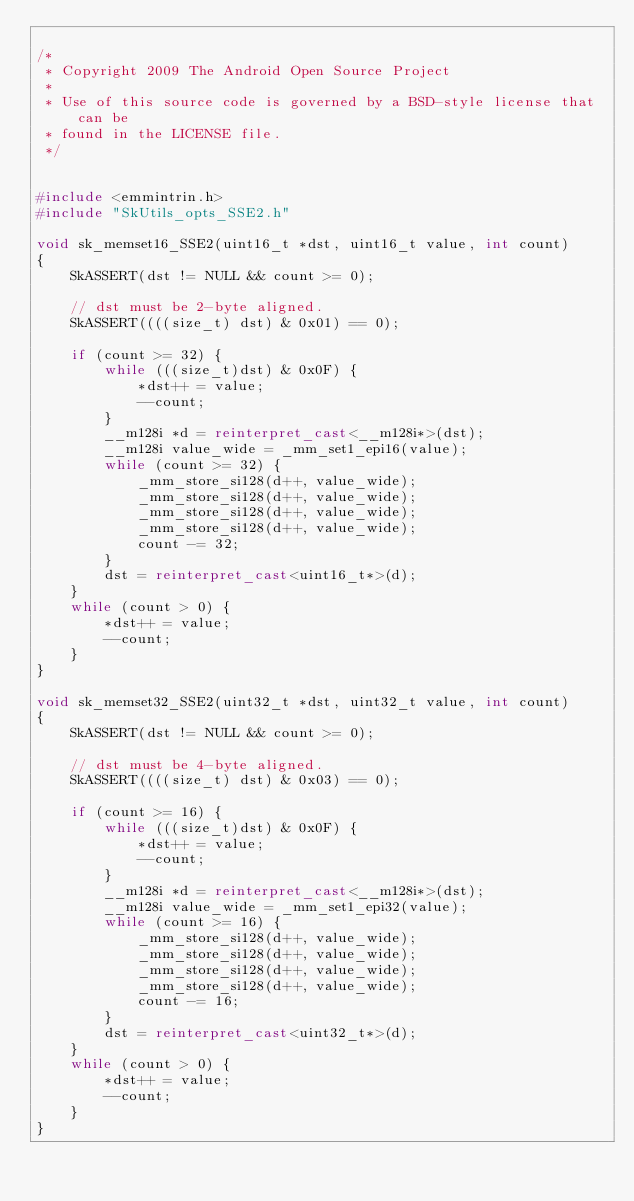<code> <loc_0><loc_0><loc_500><loc_500><_C++_>
/*
 * Copyright 2009 The Android Open Source Project
 *
 * Use of this source code is governed by a BSD-style license that can be
 * found in the LICENSE file.
 */


#include <emmintrin.h>
#include "SkUtils_opts_SSE2.h"

void sk_memset16_SSE2(uint16_t *dst, uint16_t value, int count)
{
    SkASSERT(dst != NULL && count >= 0);

    // dst must be 2-byte aligned.
    SkASSERT((((size_t) dst) & 0x01) == 0);

    if (count >= 32) {
        while (((size_t)dst) & 0x0F) {
            *dst++ = value;
            --count;
        }
        __m128i *d = reinterpret_cast<__m128i*>(dst);
        __m128i value_wide = _mm_set1_epi16(value);
        while (count >= 32) {
            _mm_store_si128(d++, value_wide);
            _mm_store_si128(d++, value_wide);
            _mm_store_si128(d++, value_wide);
            _mm_store_si128(d++, value_wide);
            count -= 32;
        }
        dst = reinterpret_cast<uint16_t*>(d);
    }
    while (count > 0) {
        *dst++ = value;
        --count;
    }
}

void sk_memset32_SSE2(uint32_t *dst, uint32_t value, int count)
{
    SkASSERT(dst != NULL && count >= 0);

    // dst must be 4-byte aligned.
    SkASSERT((((size_t) dst) & 0x03) == 0);

    if (count >= 16) {
        while (((size_t)dst) & 0x0F) {
            *dst++ = value;
            --count;
        }
        __m128i *d = reinterpret_cast<__m128i*>(dst);
        __m128i value_wide = _mm_set1_epi32(value);
        while (count >= 16) {
            _mm_store_si128(d++, value_wide);
            _mm_store_si128(d++, value_wide);
            _mm_store_si128(d++, value_wide);
            _mm_store_si128(d++, value_wide);
            count -= 16;
        }
        dst = reinterpret_cast<uint32_t*>(d);
    }
    while (count > 0) {
        *dst++ = value;
        --count;
    }
}
</code> 